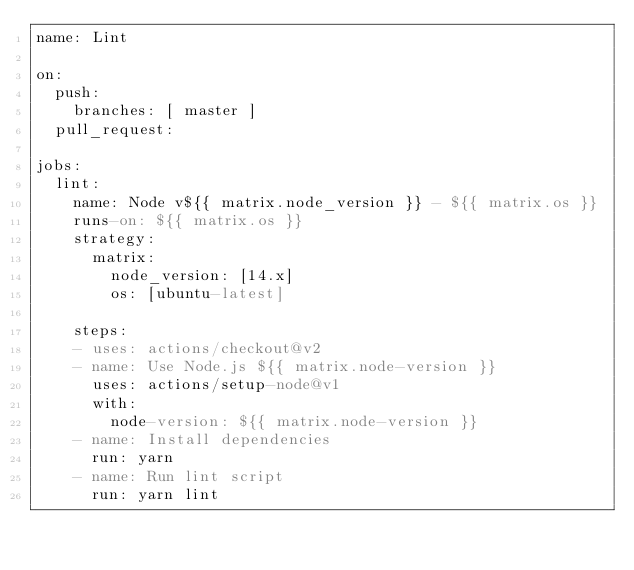Convert code to text. <code><loc_0><loc_0><loc_500><loc_500><_YAML_>name: Lint

on:
  push:
    branches: [ master ]
  pull_request:

jobs:
  lint:
    name: Node v${{ matrix.node_version }} - ${{ matrix.os }}
    runs-on: ${{ matrix.os }}
    strategy:
      matrix:
        node_version: [14.x]
        os: [ubuntu-latest]

    steps:
    - uses: actions/checkout@v2
    - name: Use Node.js ${{ matrix.node-version }}
      uses: actions/setup-node@v1
      with:
        node-version: ${{ matrix.node-version }}
    - name: Install dependencies
      run: yarn
    - name: Run lint script
      run: yarn lint</code> 